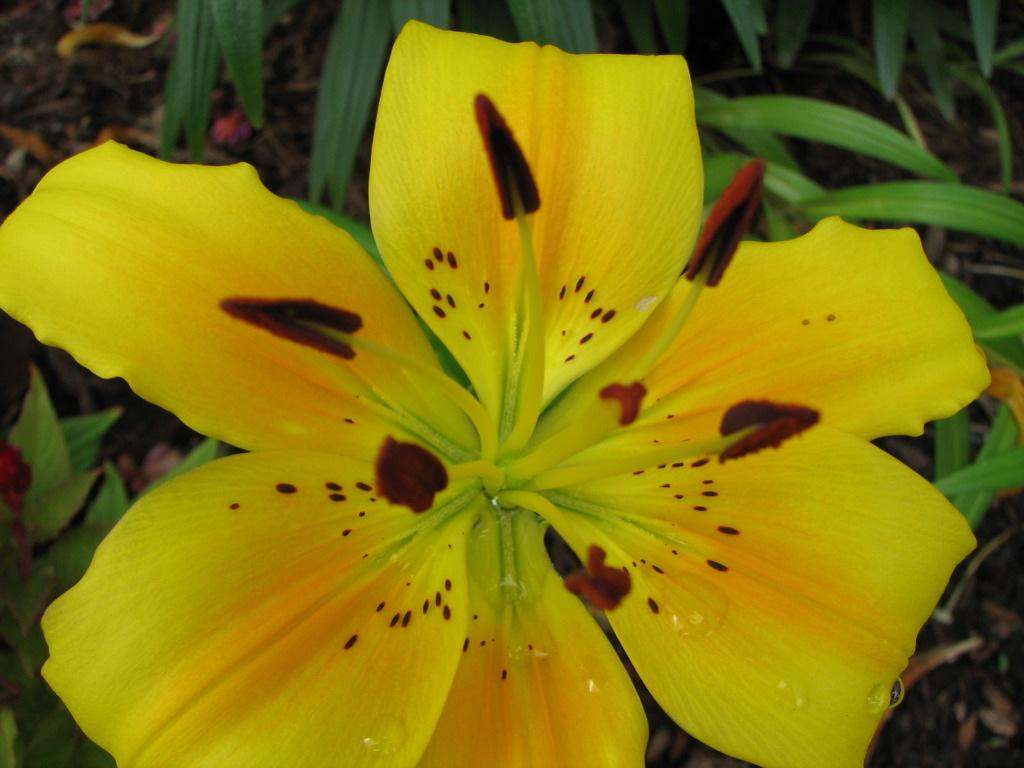What is the main subject of the image? There is a flower in the image. What can be seen in the background of the image? There are leaves and soil in the background of the image. What type of polish is being applied to the flower in the image? There is no polish being applied to the flower in the image; it is a natural plant. 